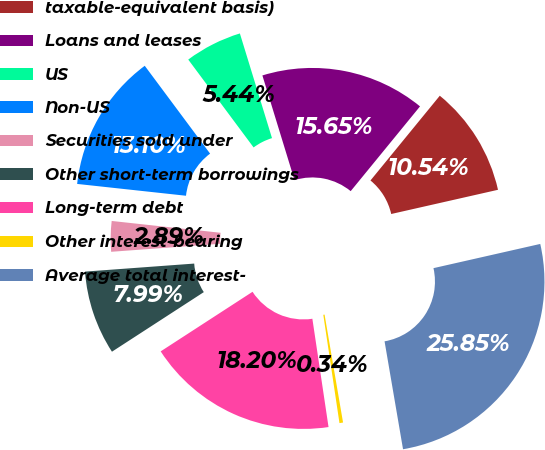Convert chart. <chart><loc_0><loc_0><loc_500><loc_500><pie_chart><fcel>taxable-equivalent basis)<fcel>Loans and leases<fcel>US<fcel>Non-US<fcel>Securities sold under<fcel>Other short-term borrowings<fcel>Long-term debt<fcel>Other interest-bearing<fcel>Average total interest-<nl><fcel>10.54%<fcel>15.65%<fcel>5.44%<fcel>13.1%<fcel>2.89%<fcel>7.99%<fcel>18.2%<fcel>0.34%<fcel>25.85%<nl></chart> 